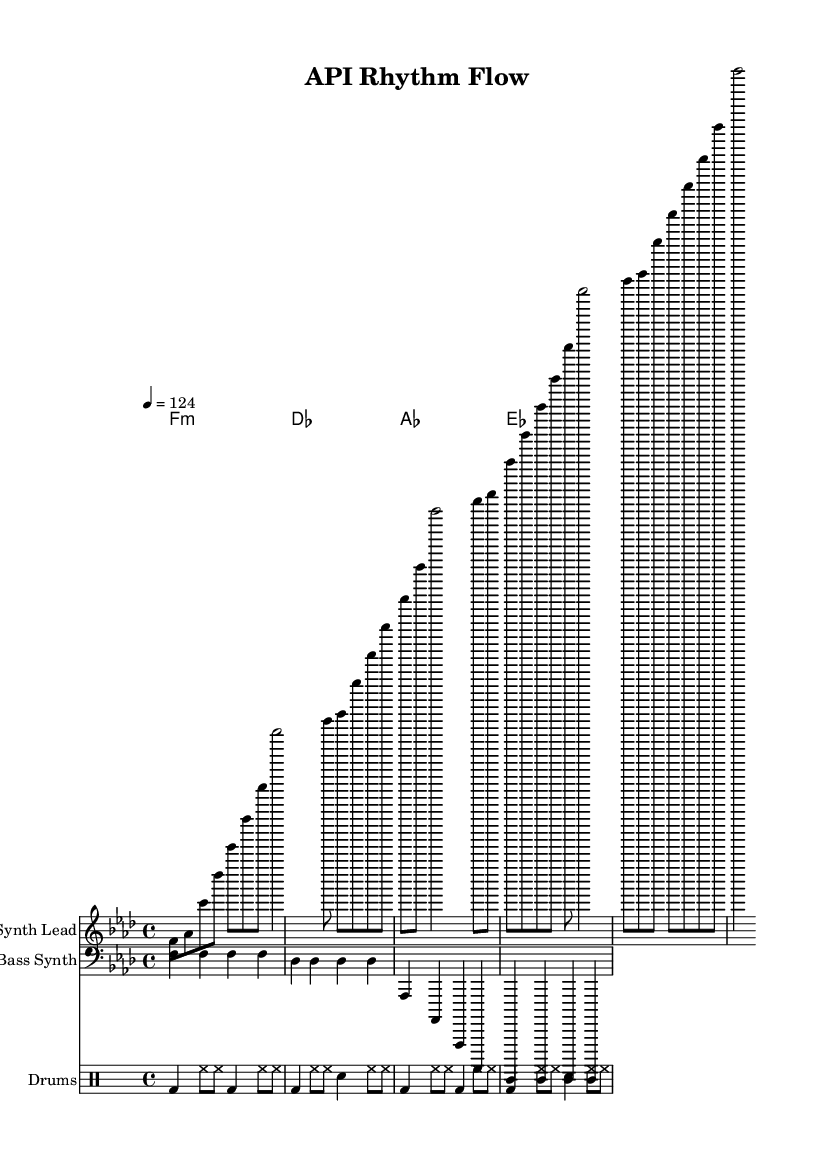What is the key signature of this music? The key signature is represented by the flat symbols on the staff. In this case, there are four flats, which indicate that the key is F major or D minor. However, the context suggests it is F minor as indicated by the starting note.
Answer: F minor What is the time signature of this music? The time signature is indicated at the beginning of the score. It is shown as a fraction, with a 4 on top and a 4 on the bottom, which means there are four beats in each measure and a quarter note receives one beat.
Answer: 4/4 What is the tempo marking of this music? The tempo marking can be found at the beginning of the score, indicated by the number followed by the equals sign. This shows that the quarter note should be played at a speed of 124 beats per minute.
Answer: 124 How many measures are in the synth lead part? To find the number of measures, count the vertical bar lines in the synth lead part. Each bar line signifies the end of a measure. The count results in four measures in total for the synth lead part.
Answer: 4 What type of drum pattern is used in this music? The drum pattern is created using a combination of bass drum, hi-hat, and snare drum, which is common in dance music, specifically deep house. The specific combination provides the driving beat typical of the genre.
Answer: Dance What is the harmonic structure of this music? The harmonic structure is represented in chord symbols above the staff. The chords follow a progression from F minor to D flat major, A flat major, and E flat major, providing a rich harmonic texture typical in deep house music.
Answer: F minor, D flat major, A flat major, E flat major Which instrument is playing the bass part? The bass part is labeled as "Bass Synth" in the score, indicating this instrument's role in the arrangement. It features a rhythmic pattern that complements the other instruments, establishing the foundational groove of the track.
Answer: Bass Synth 